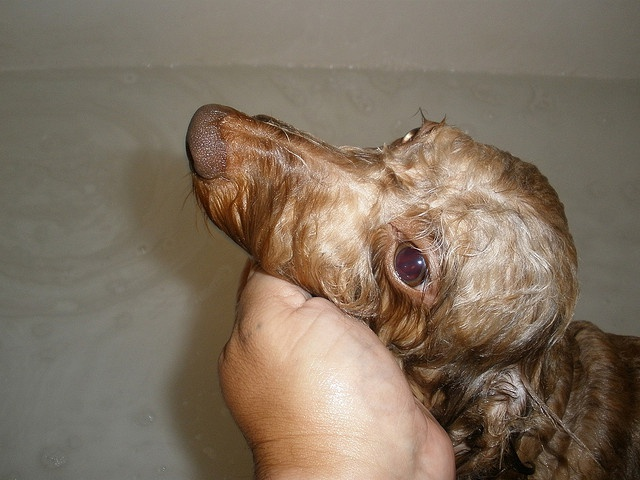Describe the objects in this image and their specific colors. I can see dog in gray, maroon, and black tones and people in gray, tan, and lightgray tones in this image. 